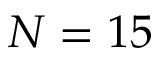<formula> <loc_0><loc_0><loc_500><loc_500>N = 1 5</formula> 